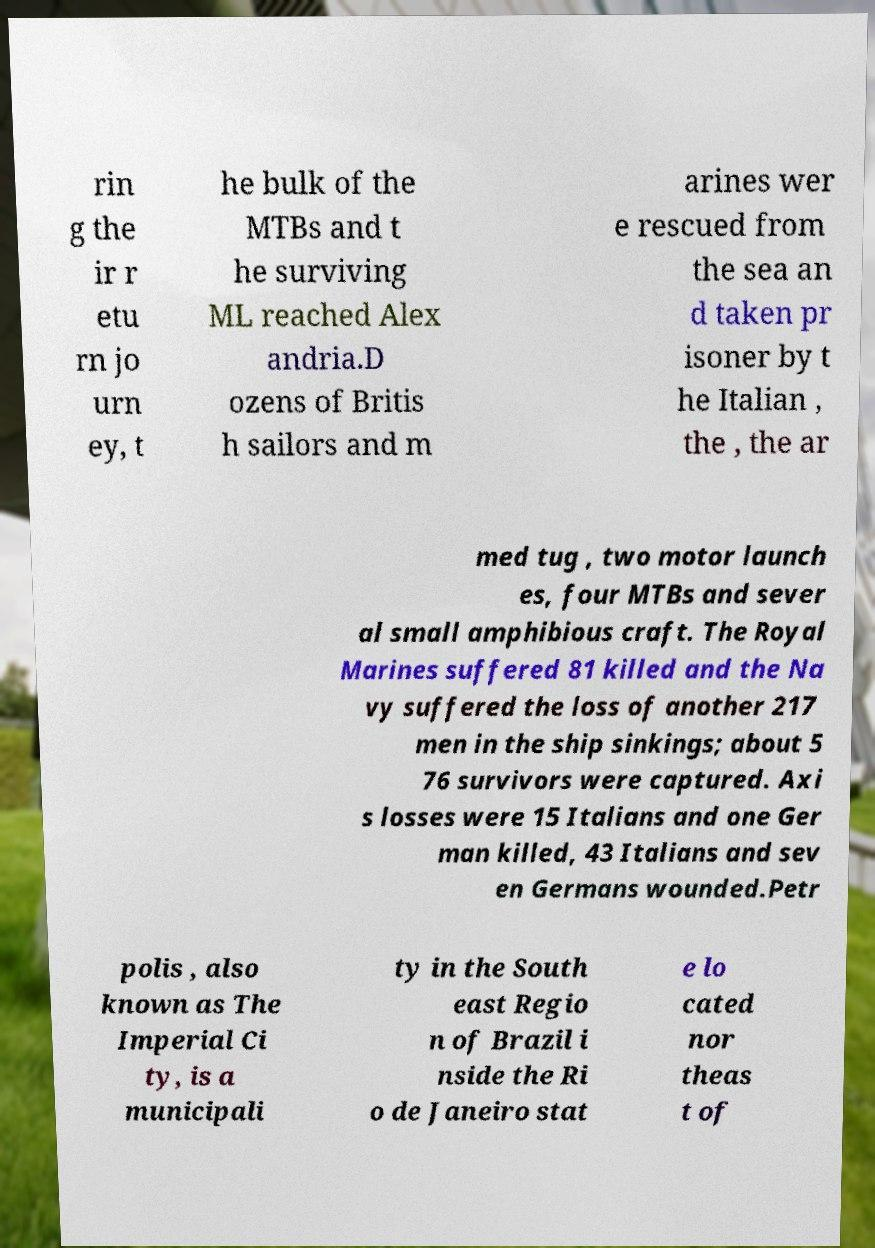Please identify and transcribe the text found in this image. rin g the ir r etu rn jo urn ey, t he bulk of the MTBs and t he surviving ML reached Alex andria.D ozens of Britis h sailors and m arines wer e rescued from the sea an d taken pr isoner by t he Italian , the , the ar med tug , two motor launch es, four MTBs and sever al small amphibious craft. The Royal Marines suffered 81 killed and the Na vy suffered the loss of another 217 men in the ship sinkings; about 5 76 survivors were captured. Axi s losses were 15 Italians and one Ger man killed, 43 Italians and sev en Germans wounded.Petr polis , also known as The Imperial Ci ty, is a municipali ty in the South east Regio n of Brazil i nside the Ri o de Janeiro stat e lo cated nor theas t of 